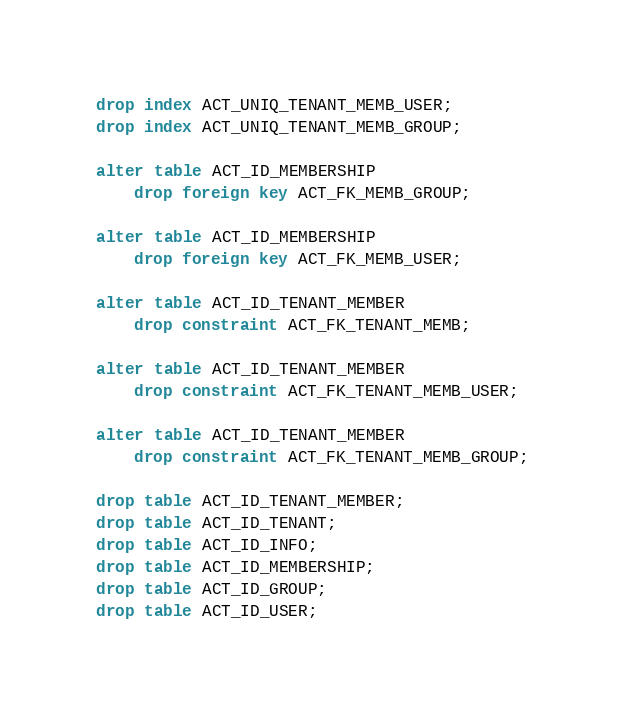Convert code to text. <code><loc_0><loc_0><loc_500><loc_500><_SQL_>drop index ACT_UNIQ_TENANT_MEMB_USER;
drop index ACT_UNIQ_TENANT_MEMB_GROUP;

alter table ACT_ID_MEMBERSHIP
    drop foreign key ACT_FK_MEMB_GROUP;

alter table ACT_ID_MEMBERSHIP
    drop foreign key ACT_FK_MEMB_USER;

alter table ACT_ID_TENANT_MEMBER
    drop constraint ACT_FK_TENANT_MEMB;

alter table ACT_ID_TENANT_MEMBER
    drop constraint ACT_FK_TENANT_MEMB_USER;

alter table ACT_ID_TENANT_MEMBER
    drop constraint ACT_FK_TENANT_MEMB_GROUP;

drop table ACT_ID_TENANT_MEMBER;
drop table ACT_ID_TENANT;
drop table ACT_ID_INFO;
drop table ACT_ID_MEMBERSHIP;
drop table ACT_ID_GROUP;
drop table ACT_ID_USER;
</code> 